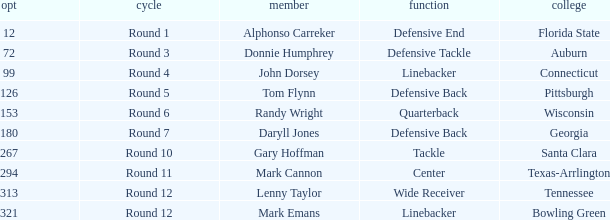In what Round was Pick #12 drafted? Round 1. 